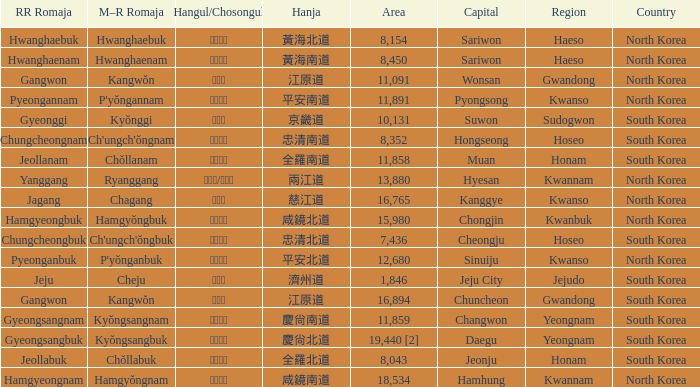What is the capital city with a hangul representation of 경상남도? Changwon. 